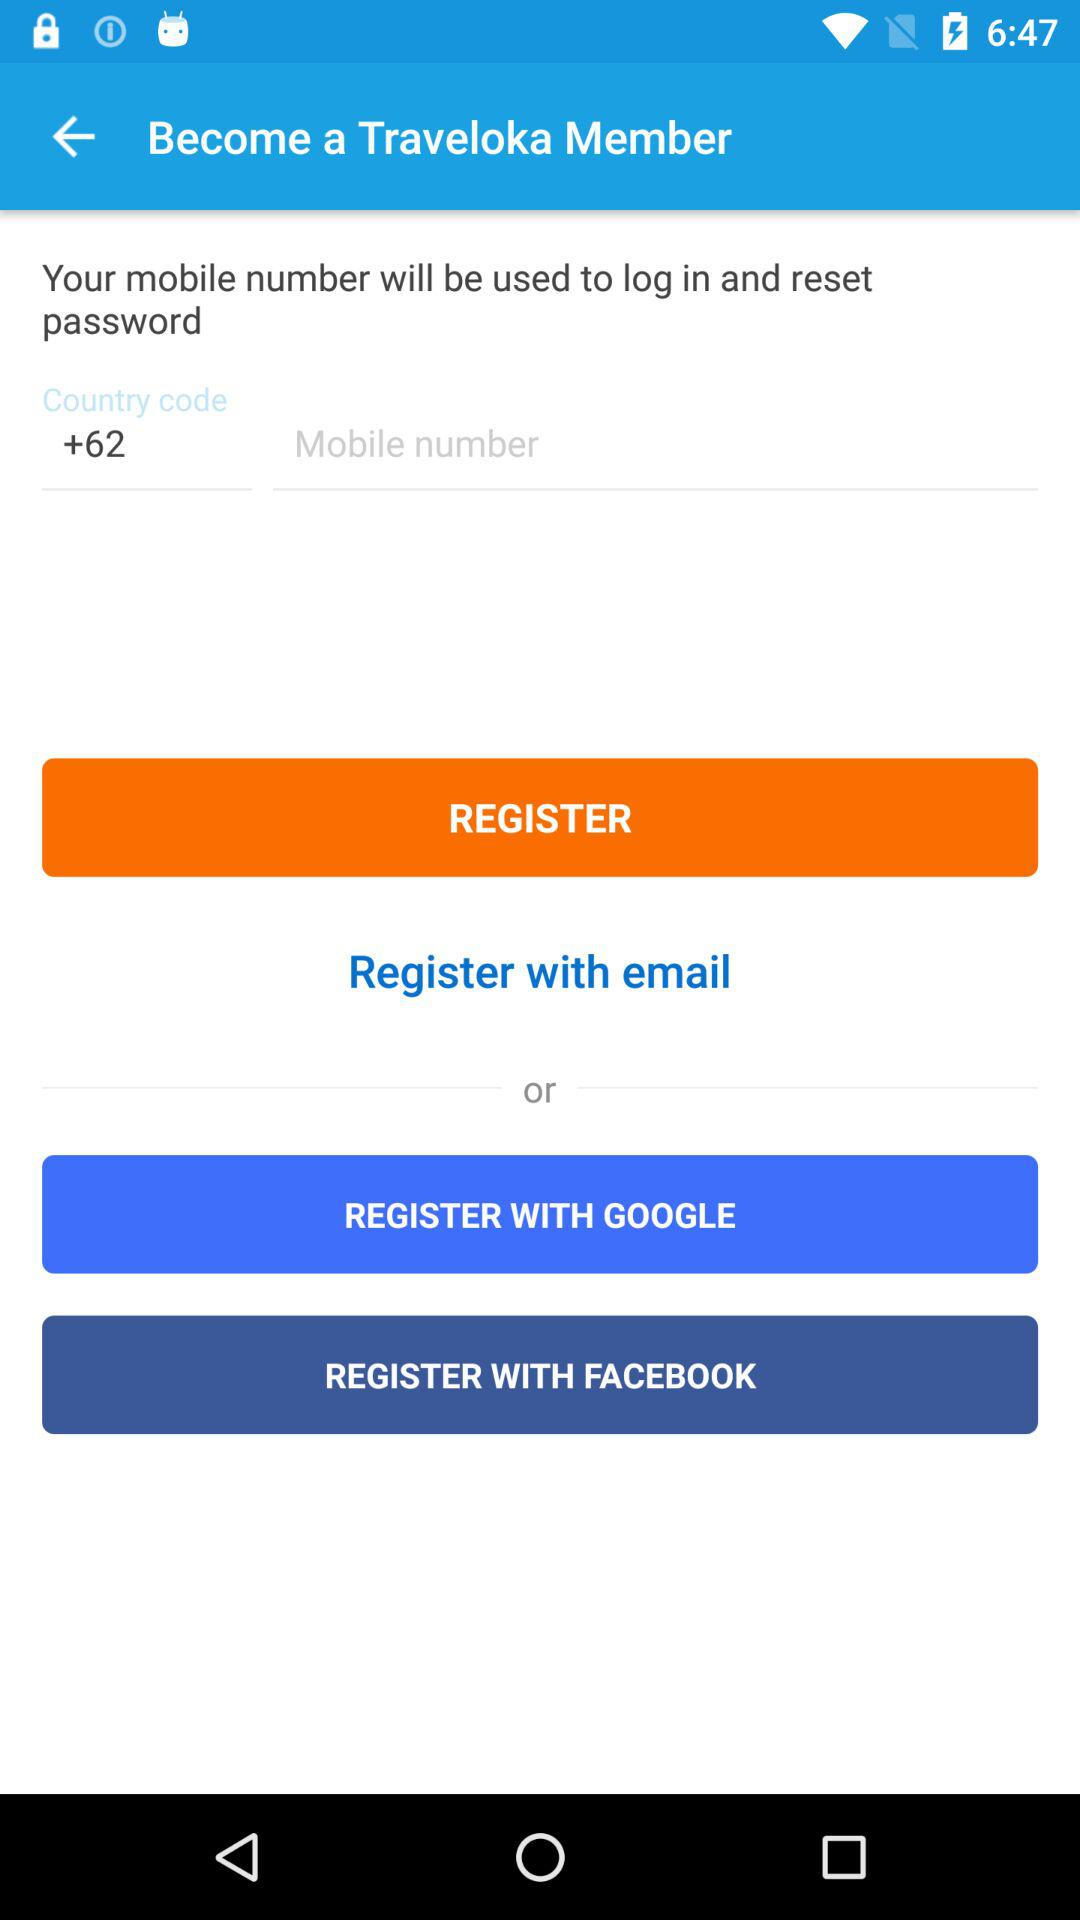Through which application can we register? You can register with "GOOGLE" and "FACEBOOK". 